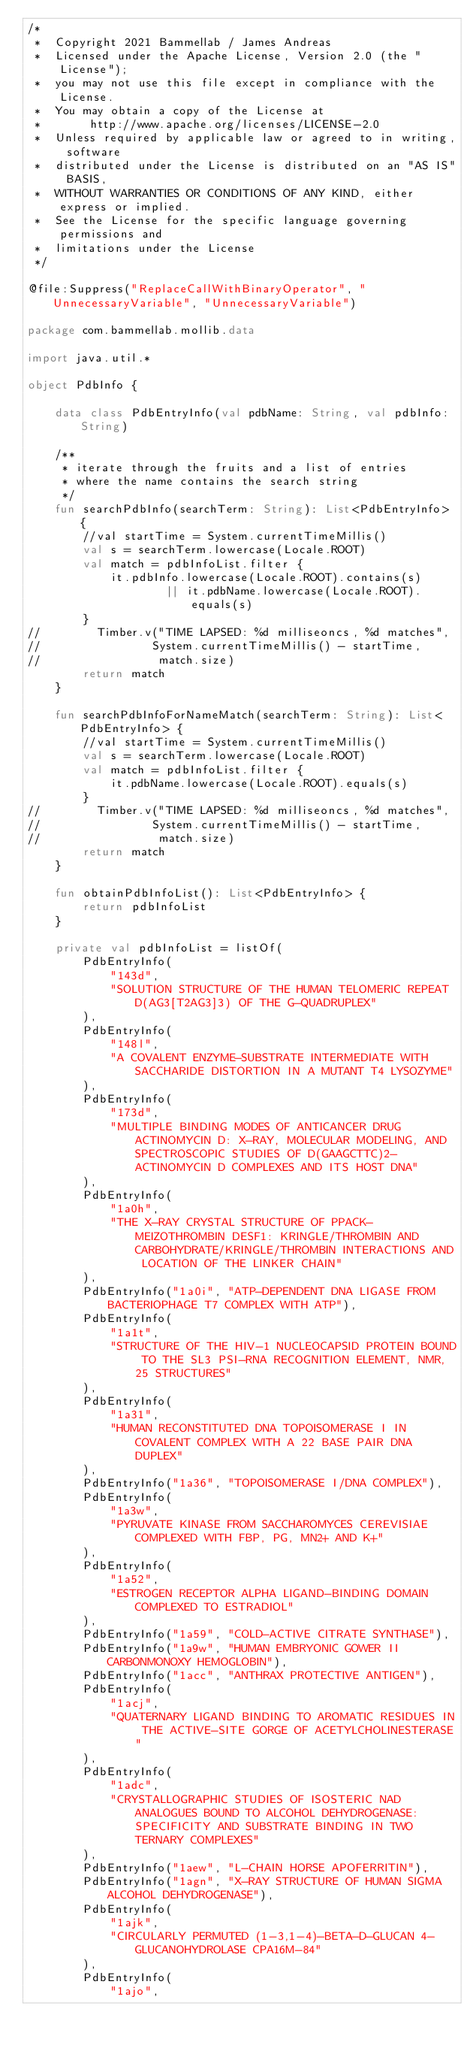Convert code to text. <code><loc_0><loc_0><loc_500><loc_500><_Kotlin_>/*
 *  Copyright 2021 Bammellab / James Andreas
 *  Licensed under the Apache License, Version 2.0 (the "License");
 *  you may not use this file except in compliance with the License.
 *  You may obtain a copy of the License at
 *       http://www.apache.org/licenses/LICENSE-2.0
 *  Unless required by applicable law or agreed to in writing, software
 *  distributed under the License is distributed on an "AS IS" BASIS,
 *  WITHOUT WARRANTIES OR CONDITIONS OF ANY KIND, either express or implied.
 *  See the License for the specific language governing permissions and
 *  limitations under the License
 */

@file:Suppress("ReplaceCallWithBinaryOperator", "UnnecessaryVariable", "UnnecessaryVariable")

package com.bammellab.mollib.data

import java.util.*

object PdbInfo {

    data class PdbEntryInfo(val pdbName: String, val pdbInfo: String)

    /**
     * iterate through the fruits and a list of entries
     * where the name contains the search string
     */
    fun searchPdbInfo(searchTerm: String): List<PdbEntryInfo> {
        //val startTime = System.currentTimeMillis()
        val s = searchTerm.lowercase(Locale.ROOT)
        val match = pdbInfoList.filter {
            it.pdbInfo.lowercase(Locale.ROOT).contains(s)
                    || it.pdbName.lowercase(Locale.ROOT).equals(s)
        }
//        Timber.v("TIME LAPSED: %d milliseoncs, %d matches",
//                System.currentTimeMillis() - startTime,
//                 match.size)
        return match
    }

    fun searchPdbInfoForNameMatch(searchTerm: String): List<PdbEntryInfo> {
        //val startTime = System.currentTimeMillis()
        val s = searchTerm.lowercase(Locale.ROOT)
        val match = pdbInfoList.filter {
            it.pdbName.lowercase(Locale.ROOT).equals(s)
        }
//        Timber.v("TIME LAPSED: %d milliseoncs, %d matches",
//                System.currentTimeMillis() - startTime,
//                 match.size)
        return match
    }

    fun obtainPdbInfoList(): List<PdbEntryInfo> {
        return pdbInfoList
    }

    private val pdbInfoList = listOf(
        PdbEntryInfo(
            "143d",
            "SOLUTION STRUCTURE OF THE HUMAN TELOMERIC REPEAT D(AG3[T2AG3]3) OF THE G-QUADRUPLEX"
        ),
        PdbEntryInfo(
            "148l",
            "A COVALENT ENZYME-SUBSTRATE INTERMEDIATE WITH SACCHARIDE DISTORTION IN A MUTANT T4 LYSOZYME"
        ),
        PdbEntryInfo(
            "173d",
            "MULTIPLE BINDING MODES OF ANTICANCER DRUG ACTINOMYCIN D: X-RAY, MOLECULAR MODELING, AND SPECTROSCOPIC STUDIES OF D(GAAGCTTC)2-ACTINOMYCIN D COMPLEXES AND ITS HOST DNA"
        ),
        PdbEntryInfo(
            "1a0h",
            "THE X-RAY CRYSTAL STRUCTURE OF PPACK-MEIZOTHROMBIN DESF1: KRINGLE/THROMBIN AND CARBOHYDRATE/KRINGLE/THROMBIN INTERACTIONS AND LOCATION OF THE LINKER CHAIN"
        ),
        PdbEntryInfo("1a0i", "ATP-DEPENDENT DNA LIGASE FROM BACTERIOPHAGE T7 COMPLEX WITH ATP"),
        PdbEntryInfo(
            "1a1t",
            "STRUCTURE OF THE HIV-1 NUCLEOCAPSID PROTEIN BOUND TO THE SL3 PSI-RNA RECOGNITION ELEMENT, NMR, 25 STRUCTURES"
        ),
        PdbEntryInfo(
            "1a31",
            "HUMAN RECONSTITUTED DNA TOPOISOMERASE I IN COVALENT COMPLEX WITH A 22 BASE PAIR DNA DUPLEX"
        ),
        PdbEntryInfo("1a36", "TOPOISOMERASE I/DNA COMPLEX"),
        PdbEntryInfo(
            "1a3w",
            "PYRUVATE KINASE FROM SACCHAROMYCES CEREVISIAE COMPLEXED WITH FBP, PG, MN2+ AND K+"
        ),
        PdbEntryInfo(
            "1a52",
            "ESTROGEN RECEPTOR ALPHA LIGAND-BINDING DOMAIN COMPLEXED TO ESTRADIOL"
        ),
        PdbEntryInfo("1a59", "COLD-ACTIVE CITRATE SYNTHASE"),
        PdbEntryInfo("1a9w", "HUMAN EMBRYONIC GOWER II CARBONMONOXY HEMOGLOBIN"),
        PdbEntryInfo("1acc", "ANTHRAX PROTECTIVE ANTIGEN"),
        PdbEntryInfo(
            "1acj",
            "QUATERNARY LIGAND BINDING TO AROMATIC RESIDUES IN THE ACTIVE-SITE GORGE OF ACETYLCHOLINESTERASE"
        ),
        PdbEntryInfo(
            "1adc",
            "CRYSTALLOGRAPHIC STUDIES OF ISOSTERIC NAD ANALOGUES BOUND TO ALCOHOL DEHYDROGENASE: SPECIFICITY AND SUBSTRATE BINDING IN TWO TERNARY COMPLEXES"
        ),
        PdbEntryInfo("1aew", "L-CHAIN HORSE APOFERRITIN"),
        PdbEntryInfo("1agn", "X-RAY STRUCTURE OF HUMAN SIGMA ALCOHOL DEHYDROGENASE"),
        PdbEntryInfo(
            "1ajk",
            "CIRCULARLY PERMUTED (1-3,1-4)-BETA-D-GLUCAN 4-GLUCANOHYDROLASE CPA16M-84"
        ),
        PdbEntryInfo(
            "1ajo",</code> 